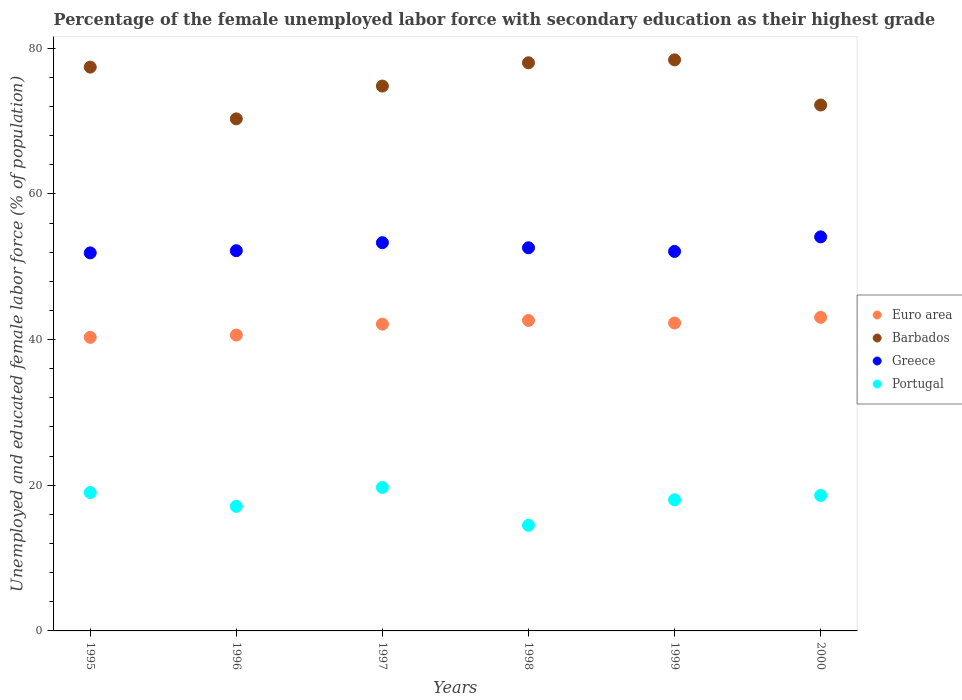Is the number of dotlines equal to the number of legend labels?
Your answer should be compact. Yes. What is the percentage of the unemployed female labor force with secondary education in Greece in 1999?
Offer a very short reply. 52.1. Across all years, what is the maximum percentage of the unemployed female labor force with secondary education in Barbados?
Provide a succinct answer. 78.4. In which year was the percentage of the unemployed female labor force with secondary education in Portugal minimum?
Make the answer very short. 1998. What is the total percentage of the unemployed female labor force with secondary education in Barbados in the graph?
Your answer should be very brief. 451.1. What is the difference between the percentage of the unemployed female labor force with secondary education in Euro area in 1995 and that in 2000?
Provide a succinct answer. -2.74. What is the difference between the percentage of the unemployed female labor force with secondary education in Euro area in 1995 and the percentage of the unemployed female labor force with secondary education in Greece in 1999?
Give a very brief answer. -11.79. What is the average percentage of the unemployed female labor force with secondary education in Greece per year?
Your answer should be very brief. 52.7. In the year 1995, what is the difference between the percentage of the unemployed female labor force with secondary education in Euro area and percentage of the unemployed female labor force with secondary education in Portugal?
Your answer should be compact. 21.31. What is the ratio of the percentage of the unemployed female labor force with secondary education in Greece in 1996 to that in 1997?
Provide a short and direct response. 0.98. Is the percentage of the unemployed female labor force with secondary education in Barbados in 1998 less than that in 2000?
Give a very brief answer. No. Is the difference between the percentage of the unemployed female labor force with secondary education in Euro area in 1995 and 2000 greater than the difference between the percentage of the unemployed female labor force with secondary education in Portugal in 1995 and 2000?
Keep it short and to the point. No. What is the difference between the highest and the second highest percentage of the unemployed female labor force with secondary education in Portugal?
Provide a succinct answer. 0.7. What is the difference between the highest and the lowest percentage of the unemployed female labor force with secondary education in Portugal?
Your answer should be very brief. 5.2. Is the percentage of the unemployed female labor force with secondary education in Greece strictly greater than the percentage of the unemployed female labor force with secondary education in Portugal over the years?
Offer a very short reply. Yes. Is the percentage of the unemployed female labor force with secondary education in Euro area strictly less than the percentage of the unemployed female labor force with secondary education in Barbados over the years?
Keep it short and to the point. Yes. How many dotlines are there?
Make the answer very short. 4. How many years are there in the graph?
Offer a very short reply. 6. Are the values on the major ticks of Y-axis written in scientific E-notation?
Provide a succinct answer. No. Where does the legend appear in the graph?
Offer a very short reply. Center right. How many legend labels are there?
Your answer should be compact. 4. How are the legend labels stacked?
Offer a terse response. Vertical. What is the title of the graph?
Make the answer very short. Percentage of the female unemployed labor force with secondary education as their highest grade. Does "Andorra" appear as one of the legend labels in the graph?
Keep it short and to the point. No. What is the label or title of the X-axis?
Ensure brevity in your answer.  Years. What is the label or title of the Y-axis?
Ensure brevity in your answer.  Unemployed and educated female labor force (% of population). What is the Unemployed and educated female labor force (% of population) in Euro area in 1995?
Provide a short and direct response. 40.31. What is the Unemployed and educated female labor force (% of population) in Barbados in 1995?
Offer a terse response. 77.4. What is the Unemployed and educated female labor force (% of population) of Greece in 1995?
Provide a succinct answer. 51.9. What is the Unemployed and educated female labor force (% of population) in Euro area in 1996?
Give a very brief answer. 40.62. What is the Unemployed and educated female labor force (% of population) in Barbados in 1996?
Offer a very short reply. 70.3. What is the Unemployed and educated female labor force (% of population) in Greece in 1996?
Offer a terse response. 52.2. What is the Unemployed and educated female labor force (% of population) in Portugal in 1996?
Make the answer very short. 17.1. What is the Unemployed and educated female labor force (% of population) in Euro area in 1997?
Your response must be concise. 42.11. What is the Unemployed and educated female labor force (% of population) in Barbados in 1997?
Your answer should be compact. 74.8. What is the Unemployed and educated female labor force (% of population) of Greece in 1997?
Make the answer very short. 53.3. What is the Unemployed and educated female labor force (% of population) of Portugal in 1997?
Provide a succinct answer. 19.7. What is the Unemployed and educated female labor force (% of population) in Euro area in 1998?
Give a very brief answer. 42.63. What is the Unemployed and educated female labor force (% of population) in Greece in 1998?
Ensure brevity in your answer.  52.6. What is the Unemployed and educated female labor force (% of population) in Portugal in 1998?
Offer a terse response. 14.5. What is the Unemployed and educated female labor force (% of population) in Euro area in 1999?
Offer a terse response. 42.27. What is the Unemployed and educated female labor force (% of population) of Barbados in 1999?
Offer a terse response. 78.4. What is the Unemployed and educated female labor force (% of population) of Greece in 1999?
Your response must be concise. 52.1. What is the Unemployed and educated female labor force (% of population) of Portugal in 1999?
Make the answer very short. 18. What is the Unemployed and educated female labor force (% of population) in Euro area in 2000?
Offer a terse response. 43.05. What is the Unemployed and educated female labor force (% of population) in Barbados in 2000?
Keep it short and to the point. 72.2. What is the Unemployed and educated female labor force (% of population) in Greece in 2000?
Ensure brevity in your answer.  54.1. What is the Unemployed and educated female labor force (% of population) of Portugal in 2000?
Provide a short and direct response. 18.6. Across all years, what is the maximum Unemployed and educated female labor force (% of population) in Euro area?
Provide a succinct answer. 43.05. Across all years, what is the maximum Unemployed and educated female labor force (% of population) of Barbados?
Offer a terse response. 78.4. Across all years, what is the maximum Unemployed and educated female labor force (% of population) in Greece?
Your answer should be very brief. 54.1. Across all years, what is the maximum Unemployed and educated female labor force (% of population) of Portugal?
Make the answer very short. 19.7. Across all years, what is the minimum Unemployed and educated female labor force (% of population) of Euro area?
Provide a short and direct response. 40.31. Across all years, what is the minimum Unemployed and educated female labor force (% of population) of Barbados?
Offer a terse response. 70.3. Across all years, what is the minimum Unemployed and educated female labor force (% of population) in Greece?
Make the answer very short. 51.9. Across all years, what is the minimum Unemployed and educated female labor force (% of population) in Portugal?
Your answer should be compact. 14.5. What is the total Unemployed and educated female labor force (% of population) of Euro area in the graph?
Keep it short and to the point. 250.99. What is the total Unemployed and educated female labor force (% of population) in Barbados in the graph?
Give a very brief answer. 451.1. What is the total Unemployed and educated female labor force (% of population) in Greece in the graph?
Ensure brevity in your answer.  316.2. What is the total Unemployed and educated female labor force (% of population) of Portugal in the graph?
Give a very brief answer. 106.9. What is the difference between the Unemployed and educated female labor force (% of population) of Euro area in 1995 and that in 1996?
Provide a short and direct response. -0.31. What is the difference between the Unemployed and educated female labor force (% of population) of Barbados in 1995 and that in 1996?
Give a very brief answer. 7.1. What is the difference between the Unemployed and educated female labor force (% of population) in Greece in 1995 and that in 1996?
Make the answer very short. -0.3. What is the difference between the Unemployed and educated female labor force (% of population) of Euro area in 1995 and that in 1997?
Offer a terse response. -1.81. What is the difference between the Unemployed and educated female labor force (% of population) in Barbados in 1995 and that in 1997?
Your answer should be very brief. 2.6. What is the difference between the Unemployed and educated female labor force (% of population) of Euro area in 1995 and that in 1998?
Provide a short and direct response. -2.32. What is the difference between the Unemployed and educated female labor force (% of population) of Greece in 1995 and that in 1998?
Your response must be concise. -0.7. What is the difference between the Unemployed and educated female labor force (% of population) of Euro area in 1995 and that in 1999?
Provide a succinct answer. -1.96. What is the difference between the Unemployed and educated female labor force (% of population) in Barbados in 1995 and that in 1999?
Provide a succinct answer. -1. What is the difference between the Unemployed and educated female labor force (% of population) of Portugal in 1995 and that in 1999?
Provide a short and direct response. 1. What is the difference between the Unemployed and educated female labor force (% of population) of Euro area in 1995 and that in 2000?
Ensure brevity in your answer.  -2.74. What is the difference between the Unemployed and educated female labor force (% of population) in Barbados in 1995 and that in 2000?
Your answer should be compact. 5.2. What is the difference between the Unemployed and educated female labor force (% of population) of Greece in 1995 and that in 2000?
Your answer should be very brief. -2.2. What is the difference between the Unemployed and educated female labor force (% of population) of Portugal in 1995 and that in 2000?
Ensure brevity in your answer.  0.4. What is the difference between the Unemployed and educated female labor force (% of population) of Euro area in 1996 and that in 1997?
Your response must be concise. -1.49. What is the difference between the Unemployed and educated female labor force (% of population) in Barbados in 1996 and that in 1997?
Give a very brief answer. -4.5. What is the difference between the Unemployed and educated female labor force (% of population) of Greece in 1996 and that in 1997?
Offer a terse response. -1.1. What is the difference between the Unemployed and educated female labor force (% of population) of Portugal in 1996 and that in 1997?
Offer a very short reply. -2.6. What is the difference between the Unemployed and educated female labor force (% of population) of Euro area in 1996 and that in 1998?
Ensure brevity in your answer.  -2.01. What is the difference between the Unemployed and educated female labor force (% of population) of Greece in 1996 and that in 1998?
Your response must be concise. -0.4. What is the difference between the Unemployed and educated female labor force (% of population) of Euro area in 1996 and that in 1999?
Your answer should be very brief. -1.65. What is the difference between the Unemployed and educated female labor force (% of population) in Barbados in 1996 and that in 1999?
Ensure brevity in your answer.  -8.1. What is the difference between the Unemployed and educated female labor force (% of population) in Euro area in 1996 and that in 2000?
Offer a terse response. -2.43. What is the difference between the Unemployed and educated female labor force (% of population) of Barbados in 1996 and that in 2000?
Provide a succinct answer. -1.9. What is the difference between the Unemployed and educated female labor force (% of population) of Greece in 1996 and that in 2000?
Your answer should be very brief. -1.9. What is the difference between the Unemployed and educated female labor force (% of population) of Euro area in 1997 and that in 1998?
Your answer should be very brief. -0.51. What is the difference between the Unemployed and educated female labor force (% of population) in Euro area in 1997 and that in 1999?
Keep it short and to the point. -0.16. What is the difference between the Unemployed and educated female labor force (% of population) in Barbados in 1997 and that in 1999?
Provide a short and direct response. -3.6. What is the difference between the Unemployed and educated female labor force (% of population) of Portugal in 1997 and that in 1999?
Make the answer very short. 1.7. What is the difference between the Unemployed and educated female labor force (% of population) of Euro area in 1997 and that in 2000?
Offer a very short reply. -0.94. What is the difference between the Unemployed and educated female labor force (% of population) of Greece in 1997 and that in 2000?
Your answer should be very brief. -0.8. What is the difference between the Unemployed and educated female labor force (% of population) of Euro area in 1998 and that in 1999?
Offer a very short reply. 0.35. What is the difference between the Unemployed and educated female labor force (% of population) in Greece in 1998 and that in 1999?
Your response must be concise. 0.5. What is the difference between the Unemployed and educated female labor force (% of population) in Euro area in 1998 and that in 2000?
Your answer should be compact. -0.42. What is the difference between the Unemployed and educated female labor force (% of population) in Euro area in 1999 and that in 2000?
Provide a succinct answer. -0.78. What is the difference between the Unemployed and educated female labor force (% of population) of Greece in 1999 and that in 2000?
Offer a very short reply. -2. What is the difference between the Unemployed and educated female labor force (% of population) in Euro area in 1995 and the Unemployed and educated female labor force (% of population) in Barbados in 1996?
Ensure brevity in your answer.  -29.99. What is the difference between the Unemployed and educated female labor force (% of population) in Euro area in 1995 and the Unemployed and educated female labor force (% of population) in Greece in 1996?
Your response must be concise. -11.89. What is the difference between the Unemployed and educated female labor force (% of population) of Euro area in 1995 and the Unemployed and educated female labor force (% of population) of Portugal in 1996?
Provide a succinct answer. 23.21. What is the difference between the Unemployed and educated female labor force (% of population) of Barbados in 1995 and the Unemployed and educated female labor force (% of population) of Greece in 1996?
Your response must be concise. 25.2. What is the difference between the Unemployed and educated female labor force (% of population) of Barbados in 1995 and the Unemployed and educated female labor force (% of population) of Portugal in 1996?
Offer a terse response. 60.3. What is the difference between the Unemployed and educated female labor force (% of population) in Greece in 1995 and the Unemployed and educated female labor force (% of population) in Portugal in 1996?
Provide a succinct answer. 34.8. What is the difference between the Unemployed and educated female labor force (% of population) in Euro area in 1995 and the Unemployed and educated female labor force (% of population) in Barbados in 1997?
Your response must be concise. -34.49. What is the difference between the Unemployed and educated female labor force (% of population) in Euro area in 1995 and the Unemployed and educated female labor force (% of population) in Greece in 1997?
Make the answer very short. -12.99. What is the difference between the Unemployed and educated female labor force (% of population) in Euro area in 1995 and the Unemployed and educated female labor force (% of population) in Portugal in 1997?
Your answer should be compact. 20.61. What is the difference between the Unemployed and educated female labor force (% of population) of Barbados in 1995 and the Unemployed and educated female labor force (% of population) of Greece in 1997?
Make the answer very short. 24.1. What is the difference between the Unemployed and educated female labor force (% of population) of Barbados in 1995 and the Unemployed and educated female labor force (% of population) of Portugal in 1997?
Give a very brief answer. 57.7. What is the difference between the Unemployed and educated female labor force (% of population) in Greece in 1995 and the Unemployed and educated female labor force (% of population) in Portugal in 1997?
Keep it short and to the point. 32.2. What is the difference between the Unemployed and educated female labor force (% of population) of Euro area in 1995 and the Unemployed and educated female labor force (% of population) of Barbados in 1998?
Provide a short and direct response. -37.69. What is the difference between the Unemployed and educated female labor force (% of population) in Euro area in 1995 and the Unemployed and educated female labor force (% of population) in Greece in 1998?
Provide a short and direct response. -12.29. What is the difference between the Unemployed and educated female labor force (% of population) in Euro area in 1995 and the Unemployed and educated female labor force (% of population) in Portugal in 1998?
Your answer should be compact. 25.81. What is the difference between the Unemployed and educated female labor force (% of population) of Barbados in 1995 and the Unemployed and educated female labor force (% of population) of Greece in 1998?
Keep it short and to the point. 24.8. What is the difference between the Unemployed and educated female labor force (% of population) in Barbados in 1995 and the Unemployed and educated female labor force (% of population) in Portugal in 1998?
Provide a succinct answer. 62.9. What is the difference between the Unemployed and educated female labor force (% of population) of Greece in 1995 and the Unemployed and educated female labor force (% of population) of Portugal in 1998?
Offer a terse response. 37.4. What is the difference between the Unemployed and educated female labor force (% of population) in Euro area in 1995 and the Unemployed and educated female labor force (% of population) in Barbados in 1999?
Your response must be concise. -38.09. What is the difference between the Unemployed and educated female labor force (% of population) of Euro area in 1995 and the Unemployed and educated female labor force (% of population) of Greece in 1999?
Offer a very short reply. -11.79. What is the difference between the Unemployed and educated female labor force (% of population) in Euro area in 1995 and the Unemployed and educated female labor force (% of population) in Portugal in 1999?
Offer a terse response. 22.31. What is the difference between the Unemployed and educated female labor force (% of population) in Barbados in 1995 and the Unemployed and educated female labor force (% of population) in Greece in 1999?
Offer a terse response. 25.3. What is the difference between the Unemployed and educated female labor force (% of population) of Barbados in 1995 and the Unemployed and educated female labor force (% of population) of Portugal in 1999?
Provide a succinct answer. 59.4. What is the difference between the Unemployed and educated female labor force (% of population) of Greece in 1995 and the Unemployed and educated female labor force (% of population) of Portugal in 1999?
Your response must be concise. 33.9. What is the difference between the Unemployed and educated female labor force (% of population) of Euro area in 1995 and the Unemployed and educated female labor force (% of population) of Barbados in 2000?
Make the answer very short. -31.89. What is the difference between the Unemployed and educated female labor force (% of population) of Euro area in 1995 and the Unemployed and educated female labor force (% of population) of Greece in 2000?
Keep it short and to the point. -13.79. What is the difference between the Unemployed and educated female labor force (% of population) in Euro area in 1995 and the Unemployed and educated female labor force (% of population) in Portugal in 2000?
Make the answer very short. 21.71. What is the difference between the Unemployed and educated female labor force (% of population) of Barbados in 1995 and the Unemployed and educated female labor force (% of population) of Greece in 2000?
Provide a short and direct response. 23.3. What is the difference between the Unemployed and educated female labor force (% of population) in Barbados in 1995 and the Unemployed and educated female labor force (% of population) in Portugal in 2000?
Give a very brief answer. 58.8. What is the difference between the Unemployed and educated female labor force (% of population) in Greece in 1995 and the Unemployed and educated female labor force (% of population) in Portugal in 2000?
Your answer should be compact. 33.3. What is the difference between the Unemployed and educated female labor force (% of population) in Euro area in 1996 and the Unemployed and educated female labor force (% of population) in Barbados in 1997?
Keep it short and to the point. -34.18. What is the difference between the Unemployed and educated female labor force (% of population) of Euro area in 1996 and the Unemployed and educated female labor force (% of population) of Greece in 1997?
Your answer should be very brief. -12.68. What is the difference between the Unemployed and educated female labor force (% of population) of Euro area in 1996 and the Unemployed and educated female labor force (% of population) of Portugal in 1997?
Ensure brevity in your answer.  20.92. What is the difference between the Unemployed and educated female labor force (% of population) of Barbados in 1996 and the Unemployed and educated female labor force (% of population) of Portugal in 1997?
Your answer should be very brief. 50.6. What is the difference between the Unemployed and educated female labor force (% of population) in Greece in 1996 and the Unemployed and educated female labor force (% of population) in Portugal in 1997?
Your response must be concise. 32.5. What is the difference between the Unemployed and educated female labor force (% of population) in Euro area in 1996 and the Unemployed and educated female labor force (% of population) in Barbados in 1998?
Offer a very short reply. -37.38. What is the difference between the Unemployed and educated female labor force (% of population) in Euro area in 1996 and the Unemployed and educated female labor force (% of population) in Greece in 1998?
Make the answer very short. -11.98. What is the difference between the Unemployed and educated female labor force (% of population) in Euro area in 1996 and the Unemployed and educated female labor force (% of population) in Portugal in 1998?
Ensure brevity in your answer.  26.12. What is the difference between the Unemployed and educated female labor force (% of population) in Barbados in 1996 and the Unemployed and educated female labor force (% of population) in Greece in 1998?
Provide a succinct answer. 17.7. What is the difference between the Unemployed and educated female labor force (% of population) of Barbados in 1996 and the Unemployed and educated female labor force (% of population) of Portugal in 1998?
Offer a very short reply. 55.8. What is the difference between the Unemployed and educated female labor force (% of population) of Greece in 1996 and the Unemployed and educated female labor force (% of population) of Portugal in 1998?
Ensure brevity in your answer.  37.7. What is the difference between the Unemployed and educated female labor force (% of population) in Euro area in 1996 and the Unemployed and educated female labor force (% of population) in Barbados in 1999?
Offer a terse response. -37.78. What is the difference between the Unemployed and educated female labor force (% of population) of Euro area in 1996 and the Unemployed and educated female labor force (% of population) of Greece in 1999?
Your response must be concise. -11.48. What is the difference between the Unemployed and educated female labor force (% of population) of Euro area in 1996 and the Unemployed and educated female labor force (% of population) of Portugal in 1999?
Offer a terse response. 22.62. What is the difference between the Unemployed and educated female labor force (% of population) in Barbados in 1996 and the Unemployed and educated female labor force (% of population) in Portugal in 1999?
Ensure brevity in your answer.  52.3. What is the difference between the Unemployed and educated female labor force (% of population) of Greece in 1996 and the Unemployed and educated female labor force (% of population) of Portugal in 1999?
Give a very brief answer. 34.2. What is the difference between the Unemployed and educated female labor force (% of population) in Euro area in 1996 and the Unemployed and educated female labor force (% of population) in Barbados in 2000?
Your response must be concise. -31.58. What is the difference between the Unemployed and educated female labor force (% of population) in Euro area in 1996 and the Unemployed and educated female labor force (% of population) in Greece in 2000?
Keep it short and to the point. -13.48. What is the difference between the Unemployed and educated female labor force (% of population) of Euro area in 1996 and the Unemployed and educated female labor force (% of population) of Portugal in 2000?
Keep it short and to the point. 22.02. What is the difference between the Unemployed and educated female labor force (% of population) in Barbados in 1996 and the Unemployed and educated female labor force (% of population) in Portugal in 2000?
Make the answer very short. 51.7. What is the difference between the Unemployed and educated female labor force (% of population) in Greece in 1996 and the Unemployed and educated female labor force (% of population) in Portugal in 2000?
Offer a very short reply. 33.6. What is the difference between the Unemployed and educated female labor force (% of population) in Euro area in 1997 and the Unemployed and educated female labor force (% of population) in Barbados in 1998?
Provide a succinct answer. -35.89. What is the difference between the Unemployed and educated female labor force (% of population) of Euro area in 1997 and the Unemployed and educated female labor force (% of population) of Greece in 1998?
Ensure brevity in your answer.  -10.49. What is the difference between the Unemployed and educated female labor force (% of population) in Euro area in 1997 and the Unemployed and educated female labor force (% of population) in Portugal in 1998?
Offer a very short reply. 27.61. What is the difference between the Unemployed and educated female labor force (% of population) in Barbados in 1997 and the Unemployed and educated female labor force (% of population) in Portugal in 1998?
Provide a succinct answer. 60.3. What is the difference between the Unemployed and educated female labor force (% of population) in Greece in 1997 and the Unemployed and educated female labor force (% of population) in Portugal in 1998?
Provide a short and direct response. 38.8. What is the difference between the Unemployed and educated female labor force (% of population) in Euro area in 1997 and the Unemployed and educated female labor force (% of population) in Barbados in 1999?
Provide a succinct answer. -36.29. What is the difference between the Unemployed and educated female labor force (% of population) of Euro area in 1997 and the Unemployed and educated female labor force (% of population) of Greece in 1999?
Make the answer very short. -9.99. What is the difference between the Unemployed and educated female labor force (% of population) of Euro area in 1997 and the Unemployed and educated female labor force (% of population) of Portugal in 1999?
Ensure brevity in your answer.  24.11. What is the difference between the Unemployed and educated female labor force (% of population) of Barbados in 1997 and the Unemployed and educated female labor force (% of population) of Greece in 1999?
Your answer should be very brief. 22.7. What is the difference between the Unemployed and educated female labor force (% of population) of Barbados in 1997 and the Unemployed and educated female labor force (% of population) of Portugal in 1999?
Give a very brief answer. 56.8. What is the difference between the Unemployed and educated female labor force (% of population) in Greece in 1997 and the Unemployed and educated female labor force (% of population) in Portugal in 1999?
Make the answer very short. 35.3. What is the difference between the Unemployed and educated female labor force (% of population) of Euro area in 1997 and the Unemployed and educated female labor force (% of population) of Barbados in 2000?
Provide a short and direct response. -30.09. What is the difference between the Unemployed and educated female labor force (% of population) in Euro area in 1997 and the Unemployed and educated female labor force (% of population) in Greece in 2000?
Keep it short and to the point. -11.99. What is the difference between the Unemployed and educated female labor force (% of population) of Euro area in 1997 and the Unemployed and educated female labor force (% of population) of Portugal in 2000?
Provide a succinct answer. 23.51. What is the difference between the Unemployed and educated female labor force (% of population) in Barbados in 1997 and the Unemployed and educated female labor force (% of population) in Greece in 2000?
Ensure brevity in your answer.  20.7. What is the difference between the Unemployed and educated female labor force (% of population) of Barbados in 1997 and the Unemployed and educated female labor force (% of population) of Portugal in 2000?
Your answer should be compact. 56.2. What is the difference between the Unemployed and educated female labor force (% of population) in Greece in 1997 and the Unemployed and educated female labor force (% of population) in Portugal in 2000?
Offer a terse response. 34.7. What is the difference between the Unemployed and educated female labor force (% of population) in Euro area in 1998 and the Unemployed and educated female labor force (% of population) in Barbados in 1999?
Your answer should be very brief. -35.77. What is the difference between the Unemployed and educated female labor force (% of population) of Euro area in 1998 and the Unemployed and educated female labor force (% of population) of Greece in 1999?
Your answer should be compact. -9.47. What is the difference between the Unemployed and educated female labor force (% of population) of Euro area in 1998 and the Unemployed and educated female labor force (% of population) of Portugal in 1999?
Offer a terse response. 24.63. What is the difference between the Unemployed and educated female labor force (% of population) in Barbados in 1998 and the Unemployed and educated female labor force (% of population) in Greece in 1999?
Provide a short and direct response. 25.9. What is the difference between the Unemployed and educated female labor force (% of population) of Greece in 1998 and the Unemployed and educated female labor force (% of population) of Portugal in 1999?
Offer a terse response. 34.6. What is the difference between the Unemployed and educated female labor force (% of population) in Euro area in 1998 and the Unemployed and educated female labor force (% of population) in Barbados in 2000?
Offer a terse response. -29.57. What is the difference between the Unemployed and educated female labor force (% of population) in Euro area in 1998 and the Unemployed and educated female labor force (% of population) in Greece in 2000?
Your answer should be very brief. -11.47. What is the difference between the Unemployed and educated female labor force (% of population) of Euro area in 1998 and the Unemployed and educated female labor force (% of population) of Portugal in 2000?
Offer a very short reply. 24.03. What is the difference between the Unemployed and educated female labor force (% of population) of Barbados in 1998 and the Unemployed and educated female labor force (% of population) of Greece in 2000?
Your response must be concise. 23.9. What is the difference between the Unemployed and educated female labor force (% of population) in Barbados in 1998 and the Unemployed and educated female labor force (% of population) in Portugal in 2000?
Give a very brief answer. 59.4. What is the difference between the Unemployed and educated female labor force (% of population) of Euro area in 1999 and the Unemployed and educated female labor force (% of population) of Barbados in 2000?
Your answer should be very brief. -29.93. What is the difference between the Unemployed and educated female labor force (% of population) of Euro area in 1999 and the Unemployed and educated female labor force (% of population) of Greece in 2000?
Your response must be concise. -11.83. What is the difference between the Unemployed and educated female labor force (% of population) in Euro area in 1999 and the Unemployed and educated female labor force (% of population) in Portugal in 2000?
Keep it short and to the point. 23.67. What is the difference between the Unemployed and educated female labor force (% of population) in Barbados in 1999 and the Unemployed and educated female labor force (% of population) in Greece in 2000?
Provide a succinct answer. 24.3. What is the difference between the Unemployed and educated female labor force (% of population) in Barbados in 1999 and the Unemployed and educated female labor force (% of population) in Portugal in 2000?
Your response must be concise. 59.8. What is the difference between the Unemployed and educated female labor force (% of population) in Greece in 1999 and the Unemployed and educated female labor force (% of population) in Portugal in 2000?
Offer a terse response. 33.5. What is the average Unemployed and educated female labor force (% of population) of Euro area per year?
Keep it short and to the point. 41.83. What is the average Unemployed and educated female labor force (% of population) in Barbados per year?
Provide a short and direct response. 75.18. What is the average Unemployed and educated female labor force (% of population) of Greece per year?
Keep it short and to the point. 52.7. What is the average Unemployed and educated female labor force (% of population) in Portugal per year?
Make the answer very short. 17.82. In the year 1995, what is the difference between the Unemployed and educated female labor force (% of population) in Euro area and Unemployed and educated female labor force (% of population) in Barbados?
Provide a succinct answer. -37.09. In the year 1995, what is the difference between the Unemployed and educated female labor force (% of population) of Euro area and Unemployed and educated female labor force (% of population) of Greece?
Your answer should be compact. -11.59. In the year 1995, what is the difference between the Unemployed and educated female labor force (% of population) in Euro area and Unemployed and educated female labor force (% of population) in Portugal?
Your answer should be very brief. 21.31. In the year 1995, what is the difference between the Unemployed and educated female labor force (% of population) of Barbados and Unemployed and educated female labor force (% of population) of Greece?
Your answer should be compact. 25.5. In the year 1995, what is the difference between the Unemployed and educated female labor force (% of population) in Barbados and Unemployed and educated female labor force (% of population) in Portugal?
Ensure brevity in your answer.  58.4. In the year 1995, what is the difference between the Unemployed and educated female labor force (% of population) of Greece and Unemployed and educated female labor force (% of population) of Portugal?
Make the answer very short. 32.9. In the year 1996, what is the difference between the Unemployed and educated female labor force (% of population) of Euro area and Unemployed and educated female labor force (% of population) of Barbados?
Keep it short and to the point. -29.68. In the year 1996, what is the difference between the Unemployed and educated female labor force (% of population) in Euro area and Unemployed and educated female labor force (% of population) in Greece?
Offer a very short reply. -11.58. In the year 1996, what is the difference between the Unemployed and educated female labor force (% of population) in Euro area and Unemployed and educated female labor force (% of population) in Portugal?
Keep it short and to the point. 23.52. In the year 1996, what is the difference between the Unemployed and educated female labor force (% of population) of Barbados and Unemployed and educated female labor force (% of population) of Portugal?
Keep it short and to the point. 53.2. In the year 1996, what is the difference between the Unemployed and educated female labor force (% of population) of Greece and Unemployed and educated female labor force (% of population) of Portugal?
Your answer should be very brief. 35.1. In the year 1997, what is the difference between the Unemployed and educated female labor force (% of population) in Euro area and Unemployed and educated female labor force (% of population) in Barbados?
Offer a very short reply. -32.69. In the year 1997, what is the difference between the Unemployed and educated female labor force (% of population) of Euro area and Unemployed and educated female labor force (% of population) of Greece?
Ensure brevity in your answer.  -11.19. In the year 1997, what is the difference between the Unemployed and educated female labor force (% of population) of Euro area and Unemployed and educated female labor force (% of population) of Portugal?
Offer a terse response. 22.41. In the year 1997, what is the difference between the Unemployed and educated female labor force (% of population) of Barbados and Unemployed and educated female labor force (% of population) of Portugal?
Provide a succinct answer. 55.1. In the year 1997, what is the difference between the Unemployed and educated female labor force (% of population) in Greece and Unemployed and educated female labor force (% of population) in Portugal?
Ensure brevity in your answer.  33.6. In the year 1998, what is the difference between the Unemployed and educated female labor force (% of population) in Euro area and Unemployed and educated female labor force (% of population) in Barbados?
Offer a very short reply. -35.37. In the year 1998, what is the difference between the Unemployed and educated female labor force (% of population) in Euro area and Unemployed and educated female labor force (% of population) in Greece?
Provide a succinct answer. -9.97. In the year 1998, what is the difference between the Unemployed and educated female labor force (% of population) in Euro area and Unemployed and educated female labor force (% of population) in Portugal?
Make the answer very short. 28.13. In the year 1998, what is the difference between the Unemployed and educated female labor force (% of population) in Barbados and Unemployed and educated female labor force (% of population) in Greece?
Ensure brevity in your answer.  25.4. In the year 1998, what is the difference between the Unemployed and educated female labor force (% of population) in Barbados and Unemployed and educated female labor force (% of population) in Portugal?
Offer a very short reply. 63.5. In the year 1998, what is the difference between the Unemployed and educated female labor force (% of population) of Greece and Unemployed and educated female labor force (% of population) of Portugal?
Provide a succinct answer. 38.1. In the year 1999, what is the difference between the Unemployed and educated female labor force (% of population) in Euro area and Unemployed and educated female labor force (% of population) in Barbados?
Provide a succinct answer. -36.13. In the year 1999, what is the difference between the Unemployed and educated female labor force (% of population) of Euro area and Unemployed and educated female labor force (% of population) of Greece?
Keep it short and to the point. -9.83. In the year 1999, what is the difference between the Unemployed and educated female labor force (% of population) of Euro area and Unemployed and educated female labor force (% of population) of Portugal?
Offer a terse response. 24.27. In the year 1999, what is the difference between the Unemployed and educated female labor force (% of population) of Barbados and Unemployed and educated female labor force (% of population) of Greece?
Your answer should be compact. 26.3. In the year 1999, what is the difference between the Unemployed and educated female labor force (% of population) in Barbados and Unemployed and educated female labor force (% of population) in Portugal?
Ensure brevity in your answer.  60.4. In the year 1999, what is the difference between the Unemployed and educated female labor force (% of population) in Greece and Unemployed and educated female labor force (% of population) in Portugal?
Offer a very short reply. 34.1. In the year 2000, what is the difference between the Unemployed and educated female labor force (% of population) in Euro area and Unemployed and educated female labor force (% of population) in Barbados?
Offer a very short reply. -29.15. In the year 2000, what is the difference between the Unemployed and educated female labor force (% of population) in Euro area and Unemployed and educated female labor force (% of population) in Greece?
Provide a succinct answer. -11.05. In the year 2000, what is the difference between the Unemployed and educated female labor force (% of population) of Euro area and Unemployed and educated female labor force (% of population) of Portugal?
Provide a short and direct response. 24.45. In the year 2000, what is the difference between the Unemployed and educated female labor force (% of population) in Barbados and Unemployed and educated female labor force (% of population) in Portugal?
Provide a succinct answer. 53.6. In the year 2000, what is the difference between the Unemployed and educated female labor force (% of population) in Greece and Unemployed and educated female labor force (% of population) in Portugal?
Keep it short and to the point. 35.5. What is the ratio of the Unemployed and educated female labor force (% of population) in Euro area in 1995 to that in 1996?
Provide a succinct answer. 0.99. What is the ratio of the Unemployed and educated female labor force (% of population) of Barbados in 1995 to that in 1996?
Provide a succinct answer. 1.1. What is the ratio of the Unemployed and educated female labor force (% of population) of Portugal in 1995 to that in 1996?
Keep it short and to the point. 1.11. What is the ratio of the Unemployed and educated female labor force (% of population) in Euro area in 1995 to that in 1997?
Provide a succinct answer. 0.96. What is the ratio of the Unemployed and educated female labor force (% of population) of Barbados in 1995 to that in 1997?
Provide a succinct answer. 1.03. What is the ratio of the Unemployed and educated female labor force (% of population) of Greece in 1995 to that in 1997?
Offer a very short reply. 0.97. What is the ratio of the Unemployed and educated female labor force (% of population) in Portugal in 1995 to that in 1997?
Offer a terse response. 0.96. What is the ratio of the Unemployed and educated female labor force (% of population) of Euro area in 1995 to that in 1998?
Offer a very short reply. 0.95. What is the ratio of the Unemployed and educated female labor force (% of population) of Barbados in 1995 to that in 1998?
Provide a short and direct response. 0.99. What is the ratio of the Unemployed and educated female labor force (% of population) in Greece in 1995 to that in 1998?
Make the answer very short. 0.99. What is the ratio of the Unemployed and educated female labor force (% of population) of Portugal in 1995 to that in 1998?
Give a very brief answer. 1.31. What is the ratio of the Unemployed and educated female labor force (% of population) of Euro area in 1995 to that in 1999?
Ensure brevity in your answer.  0.95. What is the ratio of the Unemployed and educated female labor force (% of population) of Barbados in 1995 to that in 1999?
Your answer should be compact. 0.99. What is the ratio of the Unemployed and educated female labor force (% of population) of Greece in 1995 to that in 1999?
Ensure brevity in your answer.  1. What is the ratio of the Unemployed and educated female labor force (% of population) of Portugal in 1995 to that in 1999?
Give a very brief answer. 1.06. What is the ratio of the Unemployed and educated female labor force (% of population) of Euro area in 1995 to that in 2000?
Make the answer very short. 0.94. What is the ratio of the Unemployed and educated female labor force (% of population) of Barbados in 1995 to that in 2000?
Your response must be concise. 1.07. What is the ratio of the Unemployed and educated female labor force (% of population) in Greece in 1995 to that in 2000?
Provide a short and direct response. 0.96. What is the ratio of the Unemployed and educated female labor force (% of population) in Portugal in 1995 to that in 2000?
Your answer should be compact. 1.02. What is the ratio of the Unemployed and educated female labor force (% of population) in Euro area in 1996 to that in 1997?
Make the answer very short. 0.96. What is the ratio of the Unemployed and educated female labor force (% of population) of Barbados in 1996 to that in 1997?
Offer a very short reply. 0.94. What is the ratio of the Unemployed and educated female labor force (% of population) of Greece in 1996 to that in 1997?
Provide a succinct answer. 0.98. What is the ratio of the Unemployed and educated female labor force (% of population) of Portugal in 1996 to that in 1997?
Your answer should be very brief. 0.87. What is the ratio of the Unemployed and educated female labor force (% of population) in Euro area in 1996 to that in 1998?
Ensure brevity in your answer.  0.95. What is the ratio of the Unemployed and educated female labor force (% of population) in Barbados in 1996 to that in 1998?
Ensure brevity in your answer.  0.9. What is the ratio of the Unemployed and educated female labor force (% of population) in Greece in 1996 to that in 1998?
Make the answer very short. 0.99. What is the ratio of the Unemployed and educated female labor force (% of population) of Portugal in 1996 to that in 1998?
Offer a very short reply. 1.18. What is the ratio of the Unemployed and educated female labor force (% of population) in Euro area in 1996 to that in 1999?
Your answer should be very brief. 0.96. What is the ratio of the Unemployed and educated female labor force (% of population) of Barbados in 1996 to that in 1999?
Ensure brevity in your answer.  0.9. What is the ratio of the Unemployed and educated female labor force (% of population) in Euro area in 1996 to that in 2000?
Offer a very short reply. 0.94. What is the ratio of the Unemployed and educated female labor force (% of population) of Barbados in 1996 to that in 2000?
Make the answer very short. 0.97. What is the ratio of the Unemployed and educated female labor force (% of population) in Greece in 1996 to that in 2000?
Ensure brevity in your answer.  0.96. What is the ratio of the Unemployed and educated female labor force (% of population) in Portugal in 1996 to that in 2000?
Your answer should be compact. 0.92. What is the ratio of the Unemployed and educated female labor force (% of population) of Euro area in 1997 to that in 1998?
Make the answer very short. 0.99. What is the ratio of the Unemployed and educated female labor force (% of population) in Greece in 1997 to that in 1998?
Your response must be concise. 1.01. What is the ratio of the Unemployed and educated female labor force (% of population) in Portugal in 1997 to that in 1998?
Keep it short and to the point. 1.36. What is the ratio of the Unemployed and educated female labor force (% of population) in Barbados in 1997 to that in 1999?
Your answer should be very brief. 0.95. What is the ratio of the Unemployed and educated female labor force (% of population) of Portugal in 1997 to that in 1999?
Your response must be concise. 1.09. What is the ratio of the Unemployed and educated female labor force (% of population) of Euro area in 1997 to that in 2000?
Give a very brief answer. 0.98. What is the ratio of the Unemployed and educated female labor force (% of population) of Barbados in 1997 to that in 2000?
Ensure brevity in your answer.  1.04. What is the ratio of the Unemployed and educated female labor force (% of population) of Greece in 1997 to that in 2000?
Offer a terse response. 0.99. What is the ratio of the Unemployed and educated female labor force (% of population) of Portugal in 1997 to that in 2000?
Your answer should be very brief. 1.06. What is the ratio of the Unemployed and educated female labor force (% of population) in Euro area in 1998 to that in 1999?
Your response must be concise. 1.01. What is the ratio of the Unemployed and educated female labor force (% of population) in Barbados in 1998 to that in 1999?
Provide a short and direct response. 0.99. What is the ratio of the Unemployed and educated female labor force (% of population) in Greece in 1998 to that in 1999?
Keep it short and to the point. 1.01. What is the ratio of the Unemployed and educated female labor force (% of population) in Portugal in 1998 to that in 1999?
Ensure brevity in your answer.  0.81. What is the ratio of the Unemployed and educated female labor force (% of population) in Barbados in 1998 to that in 2000?
Keep it short and to the point. 1.08. What is the ratio of the Unemployed and educated female labor force (% of population) of Greece in 1998 to that in 2000?
Keep it short and to the point. 0.97. What is the ratio of the Unemployed and educated female labor force (% of population) in Portugal in 1998 to that in 2000?
Your answer should be compact. 0.78. What is the ratio of the Unemployed and educated female labor force (% of population) in Euro area in 1999 to that in 2000?
Offer a terse response. 0.98. What is the ratio of the Unemployed and educated female labor force (% of population) in Barbados in 1999 to that in 2000?
Your response must be concise. 1.09. What is the ratio of the Unemployed and educated female labor force (% of population) of Greece in 1999 to that in 2000?
Your answer should be compact. 0.96. What is the difference between the highest and the second highest Unemployed and educated female labor force (% of population) of Euro area?
Your answer should be very brief. 0.42. What is the difference between the highest and the second highest Unemployed and educated female labor force (% of population) of Barbados?
Provide a short and direct response. 0.4. What is the difference between the highest and the second highest Unemployed and educated female labor force (% of population) of Portugal?
Provide a succinct answer. 0.7. What is the difference between the highest and the lowest Unemployed and educated female labor force (% of population) of Euro area?
Ensure brevity in your answer.  2.74. 